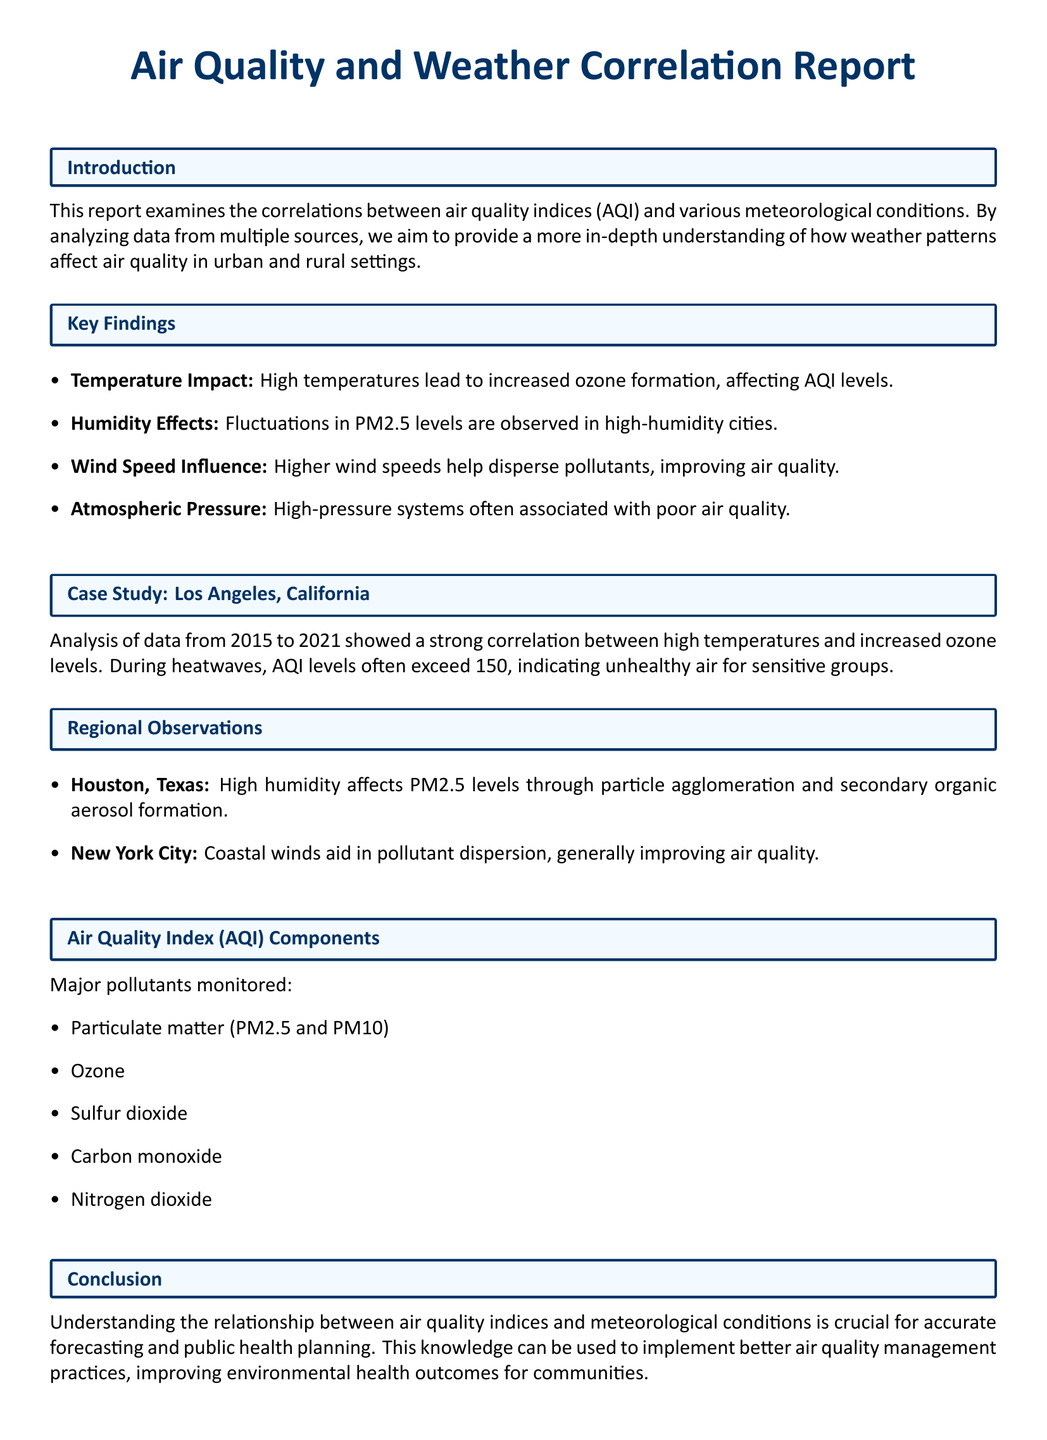What is the title of the report? The title of the report is presented at the beginning of the document.
Answer: Air Quality and Weather Correlation Report What are the major pollutants monitored? The report lists specific pollutants under the "Air Quality Index (AQI) Components" section.
Answer: Particulate matter (PM2.5 and PM10), Ozone, Sulfur dioxide, Carbon monoxide, Nitrogen dioxide Which city is analyzed in the case study? The city is specified in the case study section of the report.
Answer: Los Angeles, California What is the AQI level indicating unhealthy air for sensitive groups? The report defines a specific AQI level in the case study section.
Answer: 150 What effect do higher wind speeds have on air quality? The report describes the impact of wind speed in the "Key Findings" section.
Answer: Improve air quality How does humidity affect PM2.5 levels in Houston, Texas? The report provides insight into the relationship between humidity and PM2.5 levels in the regional observations.
Answer: Through particle agglomeration and secondary organic aerosol formation What is the conclusion regarding air quality and meteorological conditions? The conclusion summarizes the importance of understanding the relationship discussed throughout the document.
Answer: Crucial for accurate forecasting and public health planning What is the impact of high temperatures on ozone levels? The report highlights this relationship in the "Key Findings" section and in the case study.
Answer: Increased ozone formation 